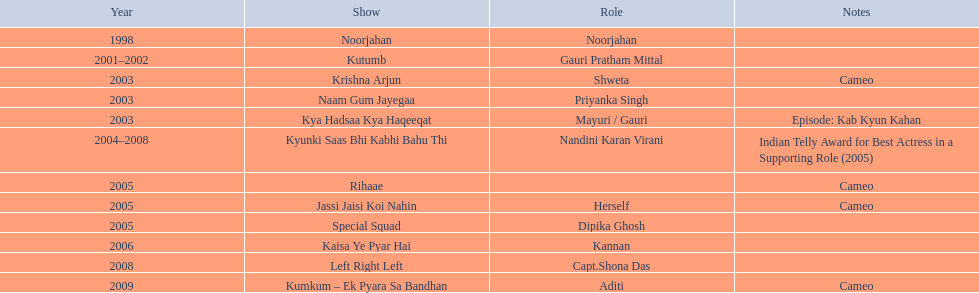Which tv shows starred gauri tejwani? Noorjahan, Kutumb, Krishna Arjun, Naam Gum Jayegaa, Kya Hadsaa Kya Haqeeqat, Kyunki Saas Bhi Kabhi Bahu Thi, Rihaae, Jassi Jaisi Koi Nahin, Special Squad, Kaisa Ye Pyar Hai, Left Right Left, Kumkum – Ek Pyara Sa Bandhan. Which shows were from 2005? Rihaae, Jassi Jaisi Koi Nahin, Special Squad. Which of them had her in brief roles? Rihaae, Jassi Jaisi Koi Nahin. Which one wasn't rihaee? Jassi Jaisi Koi Nahin. 